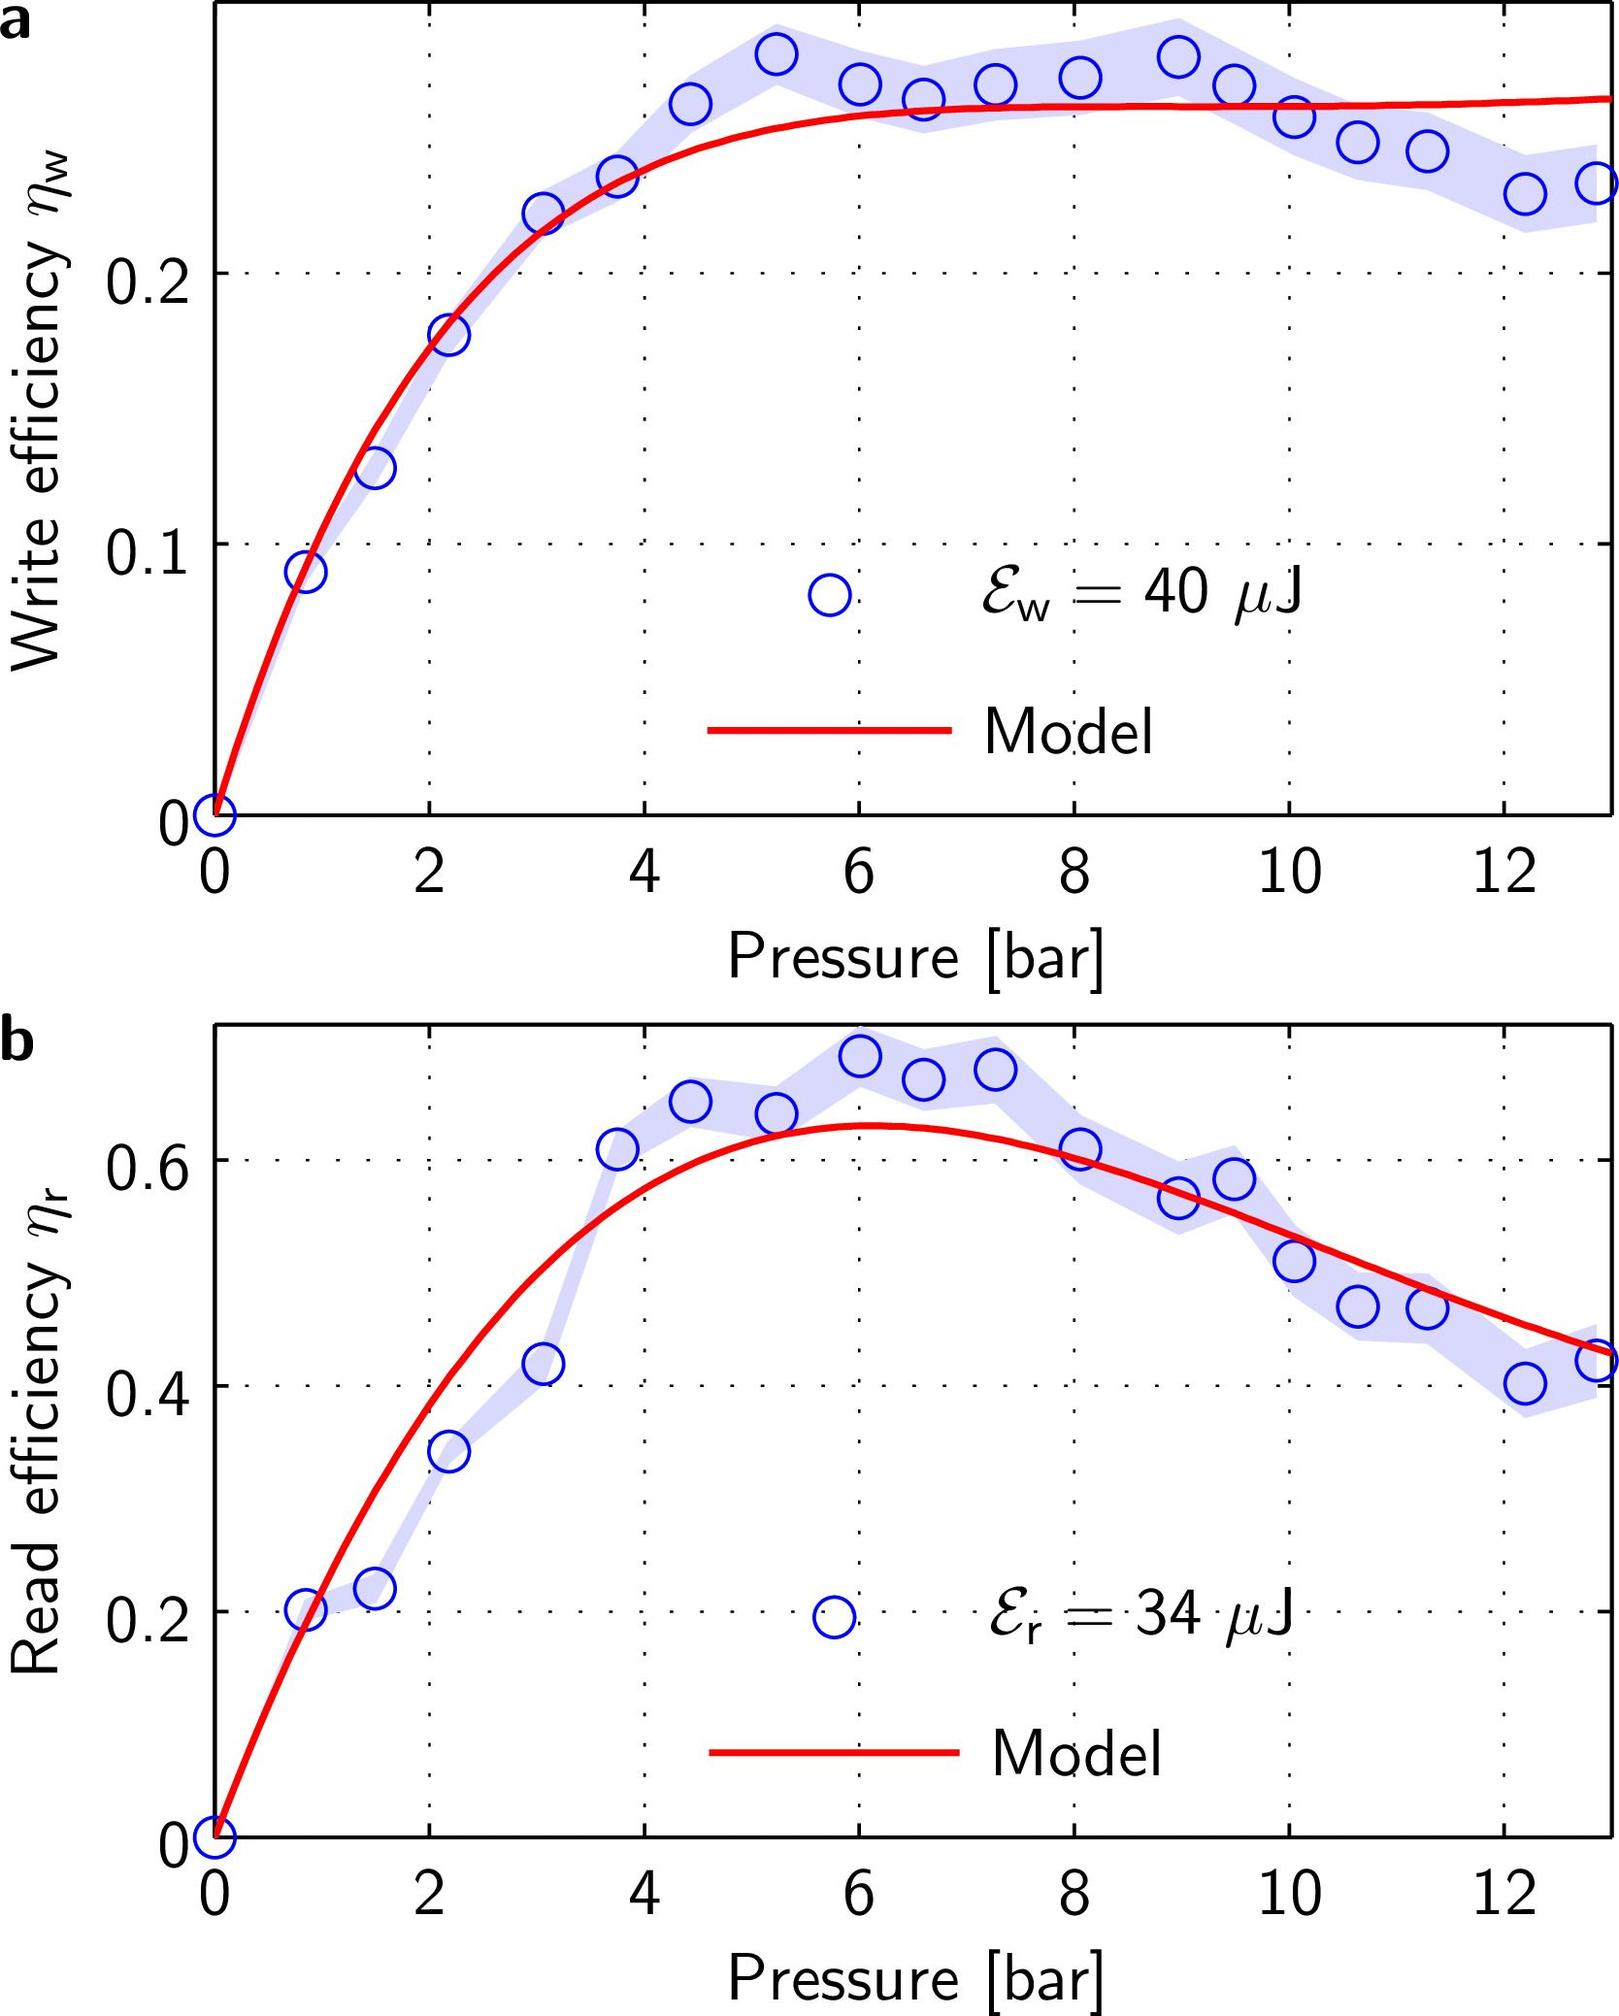If the energy utilized for writing (\(E_W\)) is increased from 40 \\(\muJ\\), what could be the expected effect on the write efficiency (\(\eta_W\))? A. The peak efficiency would shift to a lower pressure value. B. The write efficiency would decrease at all pressures. C. The peak efficiency would shift to a higher pressure value. D. The write efficiency would remain unchanged. Analyzing the graph shown in part 'a', which details the relationship between pressure and write efficiency (\(\eta_W\)) at a fixed energy input of 40 \\(\muJ\\), we can see that the efficiency peaks between 6 and 8 bar. An increase in the energy utilized for writing typically means the system could achieve similar efficiencies at a reduced input pressure. This is because higher input energy compensates for the lower pressure, allowing for greater particle motion at lower pressures, potentially moving the peak efficiency leftward on the pressure scale. Therefore, the answer is A: The peak efficiency would shift to a lower pressure value. 